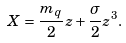Convert formula to latex. <formula><loc_0><loc_0><loc_500><loc_500>X = \frac { m _ { q } } { 2 } z + \frac { \sigma } { 2 } z ^ { 3 } .</formula> 